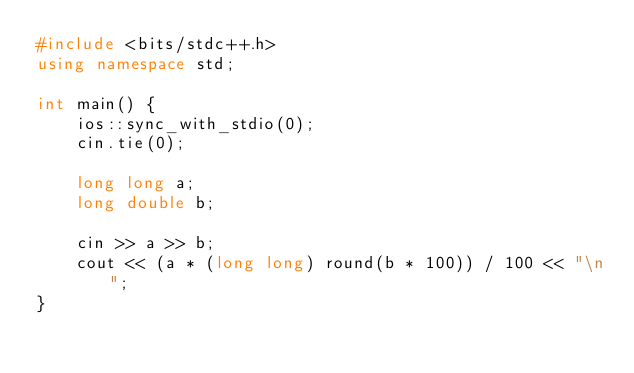<code> <loc_0><loc_0><loc_500><loc_500><_C++_>#include <bits/stdc++.h>
using namespace std;

int main() {
    ios::sync_with_stdio(0);
    cin.tie(0);

    long long a;
    long double b;

    cin >> a >> b;
    cout << (a * (long long) round(b * 100)) / 100 << "\n";
}</code> 